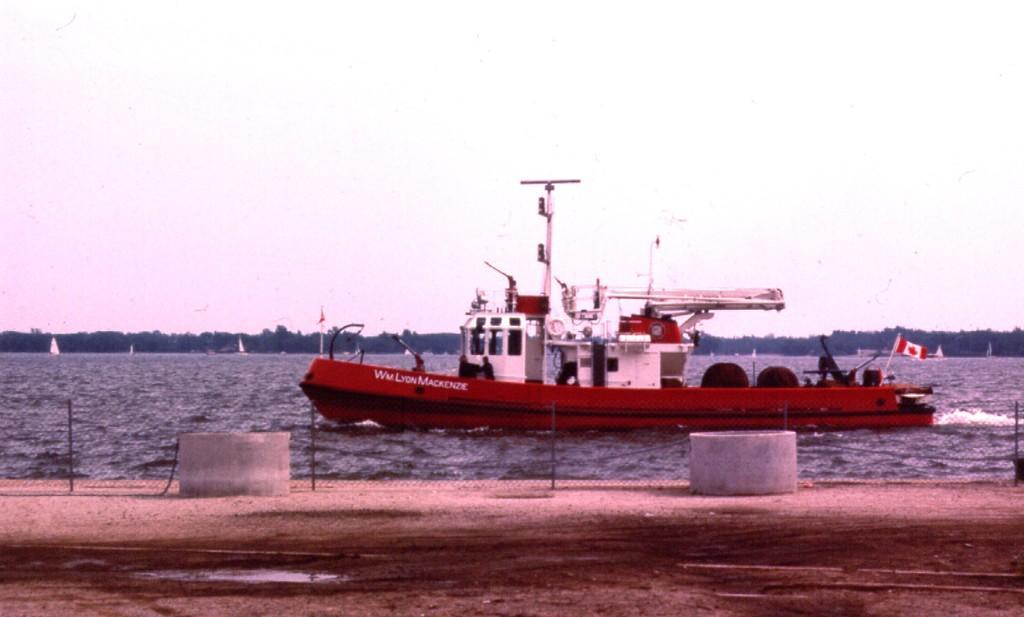How would you summarize this image in a sentence or two? We can see containers, fence and boat above the water. We can see flags and sails. In the background we can see trees and sky. 